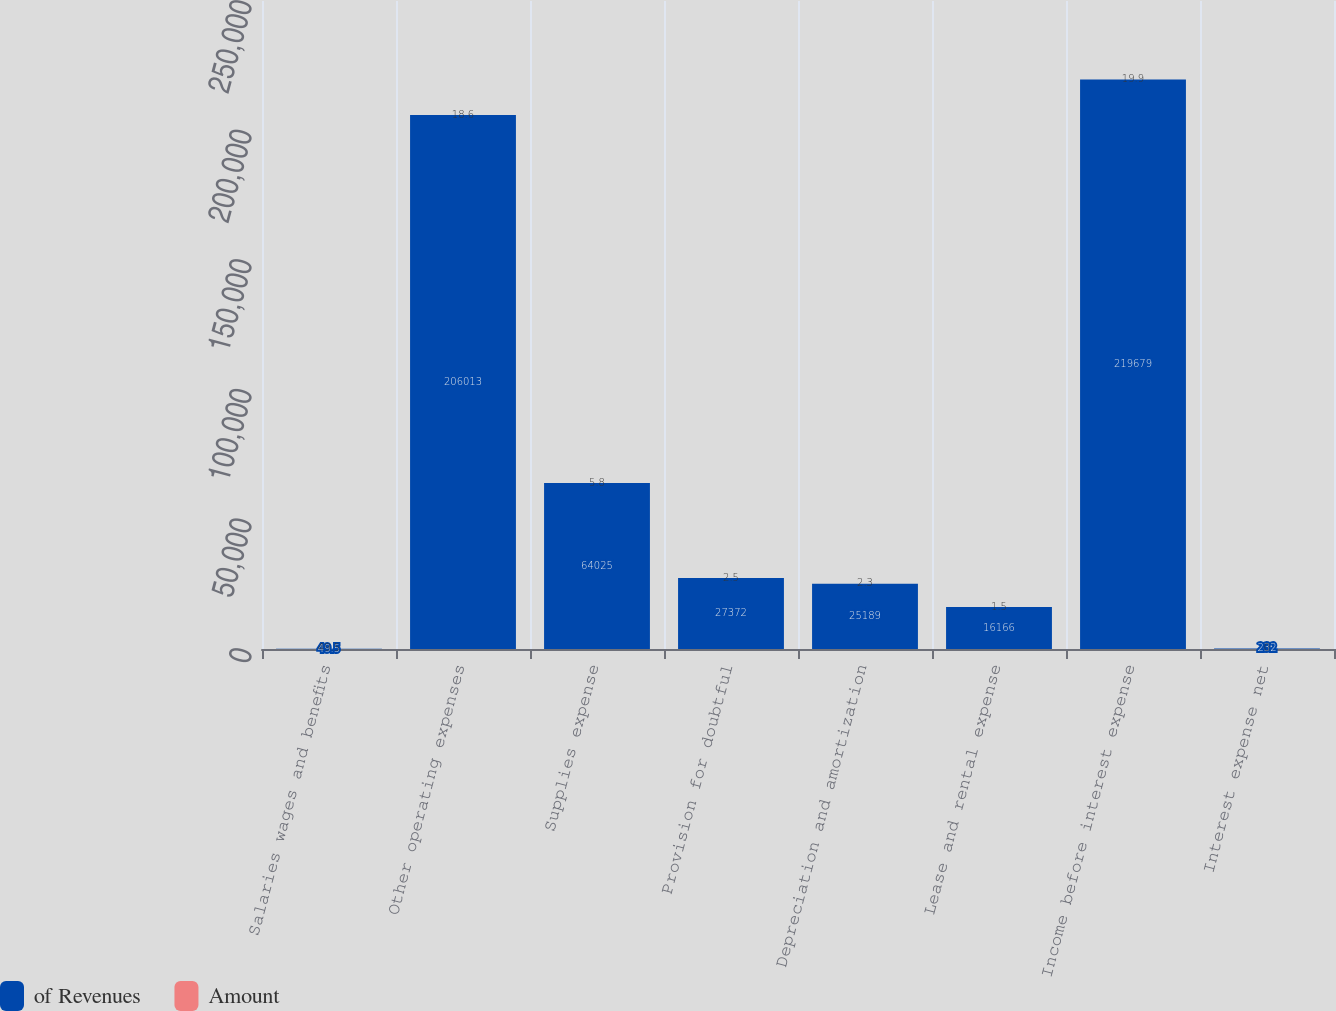Convert chart to OTSL. <chart><loc_0><loc_0><loc_500><loc_500><stacked_bar_chart><ecel><fcel>Salaries wages and benefits<fcel>Other operating expenses<fcel>Supplies expense<fcel>Provision for doubtful<fcel>Depreciation and amortization<fcel>Lease and rental expense<fcel>Income before interest expense<fcel>Interest expense net<nl><fcel>of Revenues<fcel>49.5<fcel>206013<fcel>64025<fcel>27372<fcel>25189<fcel>16166<fcel>219679<fcel>232<nl><fcel>Amount<fcel>49.5<fcel>18.6<fcel>5.8<fcel>2.5<fcel>2.3<fcel>1.5<fcel>19.9<fcel>0<nl></chart> 